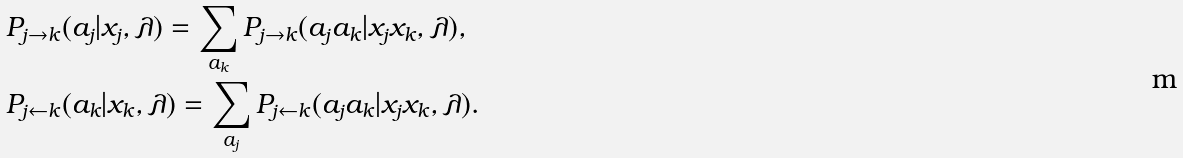<formula> <loc_0><loc_0><loc_500><loc_500>& P _ { j \rightarrow k } ( a _ { j } | x _ { j } , \lambda ) = \sum _ { a _ { k } } P _ { j \rightarrow k } ( a _ { j } a _ { k } | x _ { j } x _ { k } , \lambda ) , \\ & P _ { j \leftarrow k } ( a _ { k } | x _ { k } , \lambda ) = \sum _ { a _ { j } } P _ { j \leftarrow k } ( a _ { j } a _ { k } | x _ { j } x _ { k } , \lambda ) .</formula> 